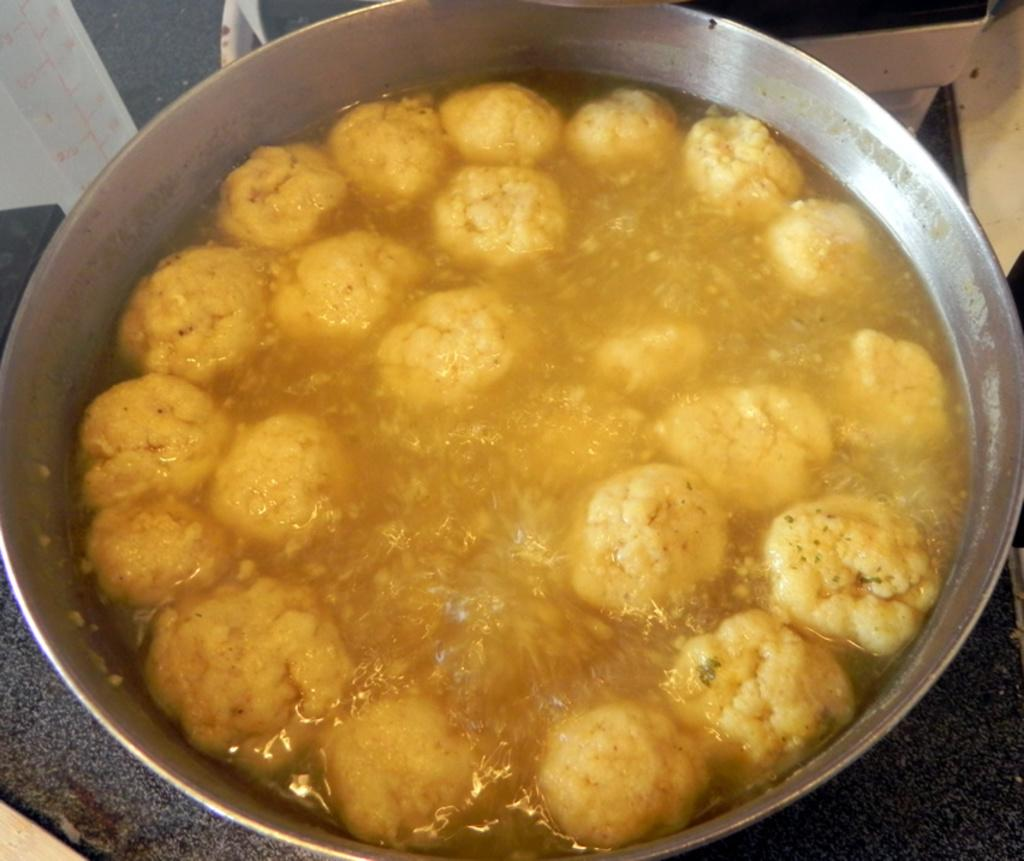What is in the bowl that is visible in the image? There is food in a bowl in the image. What else can be seen in the image besides the bowl of food? There are objects on a surface in the image. What type of ball is being used to say good-bye in the image? There is no ball or good-bye gesture present in the image. 